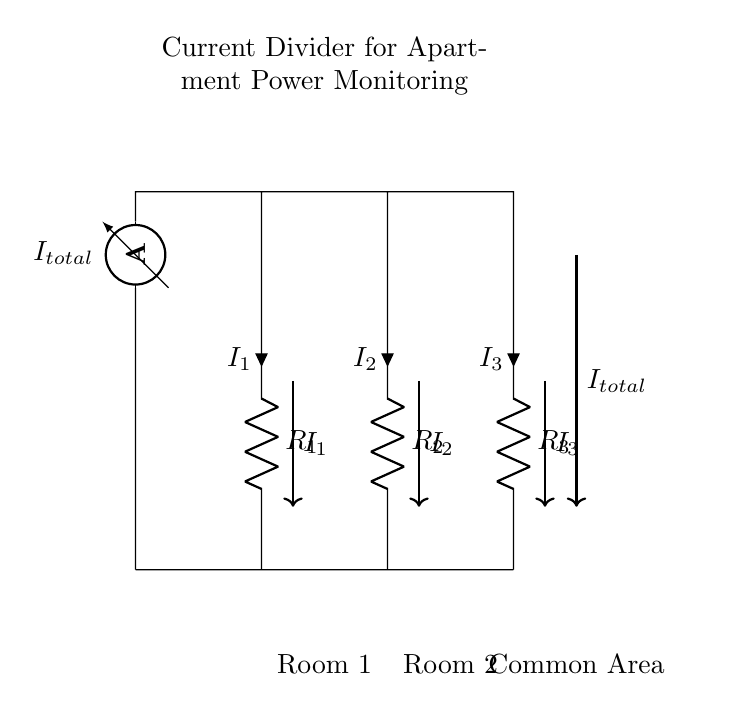What does the ammeter measure in this circuit? The ammeter measures the total current flowing through the circuit, which is indicated as I total.
Answer: total current How many resistors are in the circuit? There are three resistors present in the circuit, labeled as R one, R two, and R three.
Answer: three What is the current flowing through R two? The current flowing through R two is indicated as I two in the diagram. This current is a portion of the total current I total, distributed according to the resistance values.
Answer: I two What are the different areas represented in the circuit? The diagram shows three distinct areas: Room one, Room two, and the Common Area, which correspond to where the resistors and current flows are located.
Answer: Room one, Room two, Common Area If the total current is 12 Amperes and R one is double the value of R two, how is the current divided? According to the current divider principle, the current will be distributed inversely proportional to the resistance values. Assuming R one is 2R and R two is R, I one will be 8 Amperes, and I two will be 4 Amperes, while I three can be derived based on the remaining current from I total.
Answer: I one: 8 Amperes, I two: 4 Amperes, I three: 0 Amperes Which component allows monitoring the current flow? The component that allows monitoring the current flow is the ammeter, which is located at the top of the circuit. It measures the current before it is divided among the resistors.
Answer: ammeter What relationship governs the current division in the circuit? The current division is governed by the current divider rule, which states that the current through each resistor is inversely proportional to the resistance values in parallel.
Answer: current divider rule 